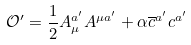Convert formula to latex. <formula><loc_0><loc_0><loc_500><loc_500>\mathcal { O } ^ { \prime } = \frac { 1 } { 2 } A _ { \mu } ^ { a ^ { \prime } } A ^ { \mu a ^ { \prime } } + \alpha \overline { c } ^ { a ^ { \prime } } c ^ { a ^ { \prime } }</formula> 